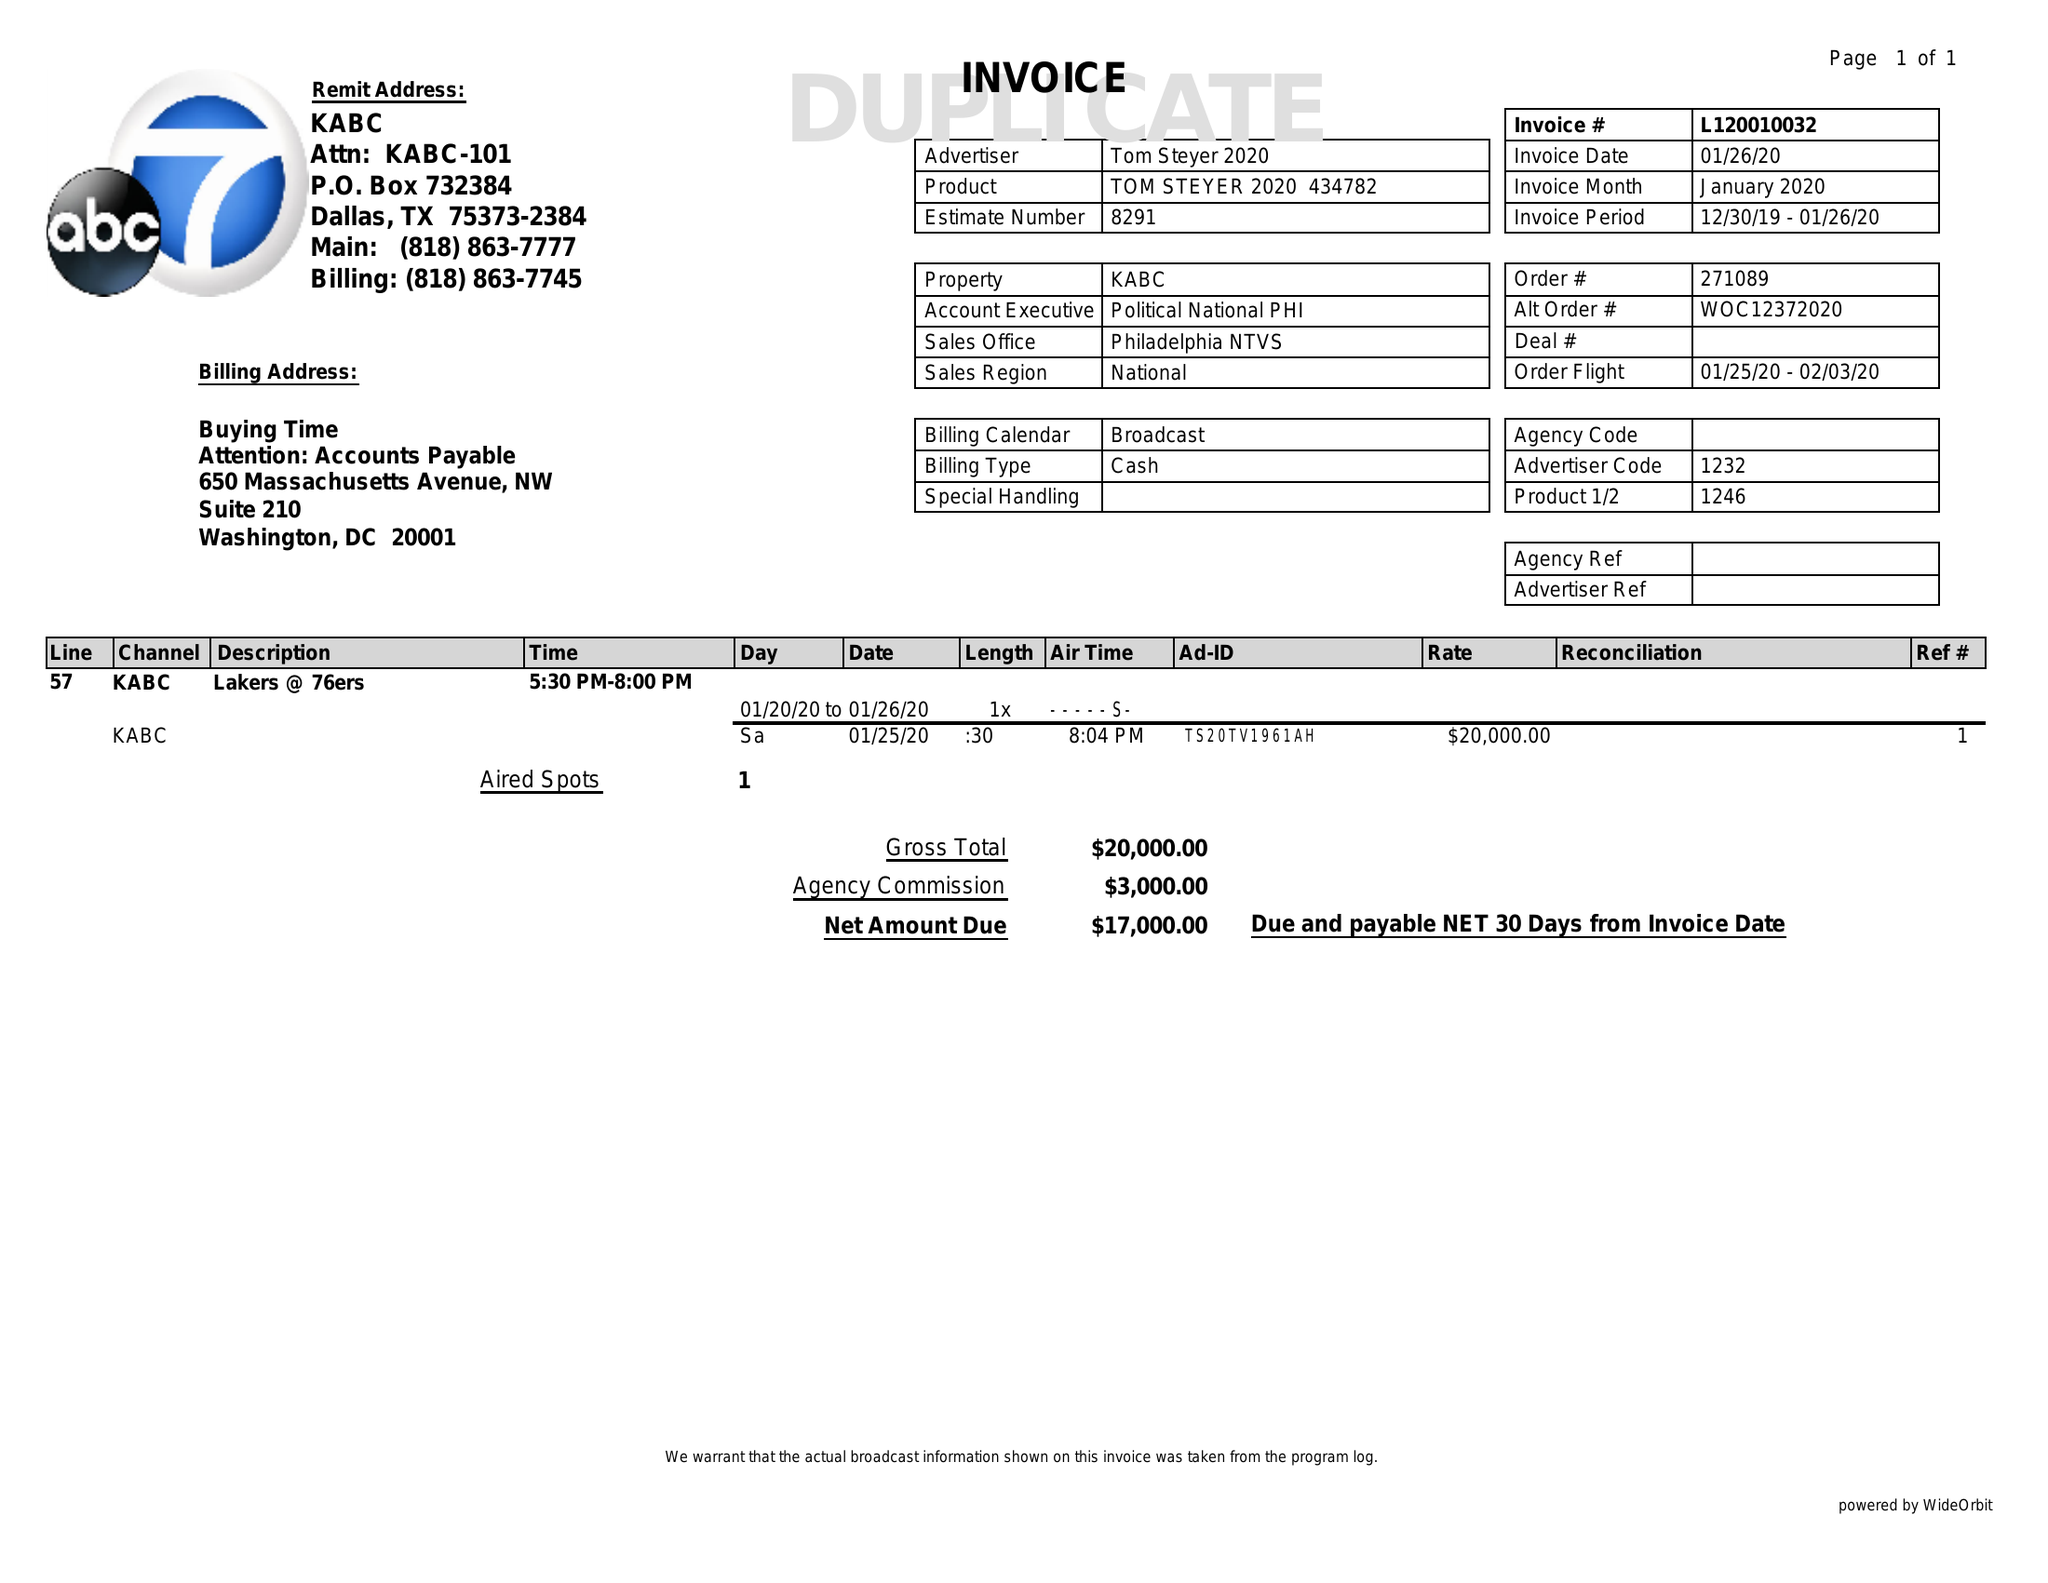What is the value for the flight_from?
Answer the question using a single word or phrase. 01/25/20 